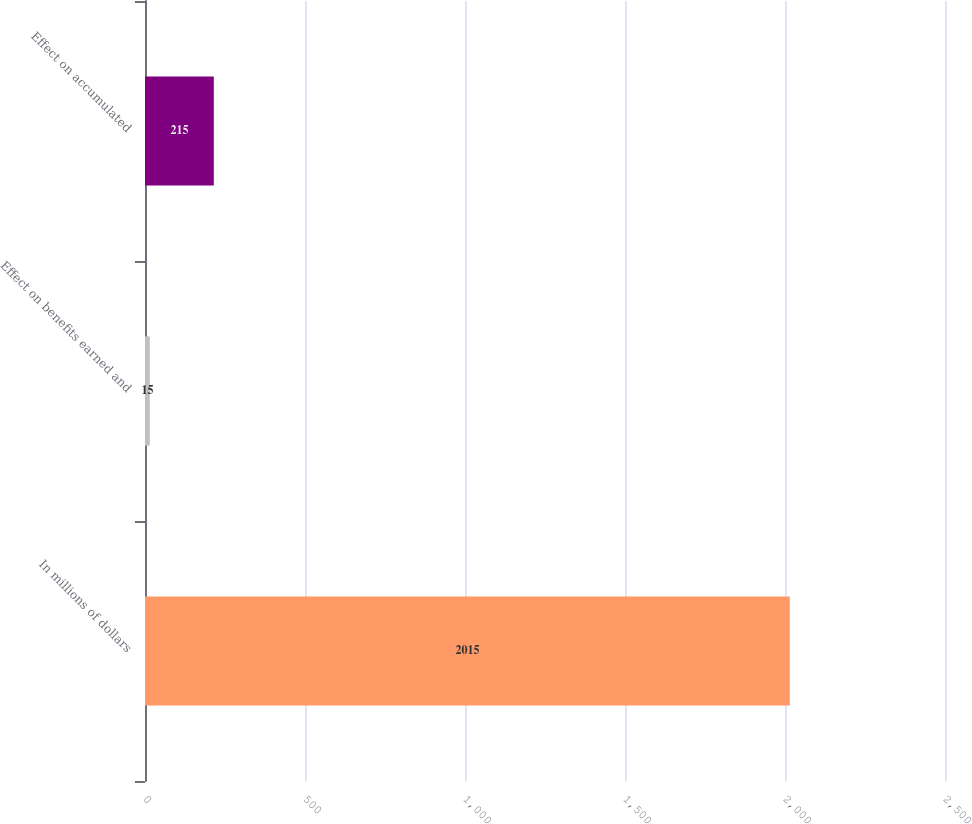Convert chart to OTSL. <chart><loc_0><loc_0><loc_500><loc_500><bar_chart><fcel>In millions of dollars<fcel>Effect on benefits earned and<fcel>Effect on accumulated<nl><fcel>2015<fcel>15<fcel>215<nl></chart> 